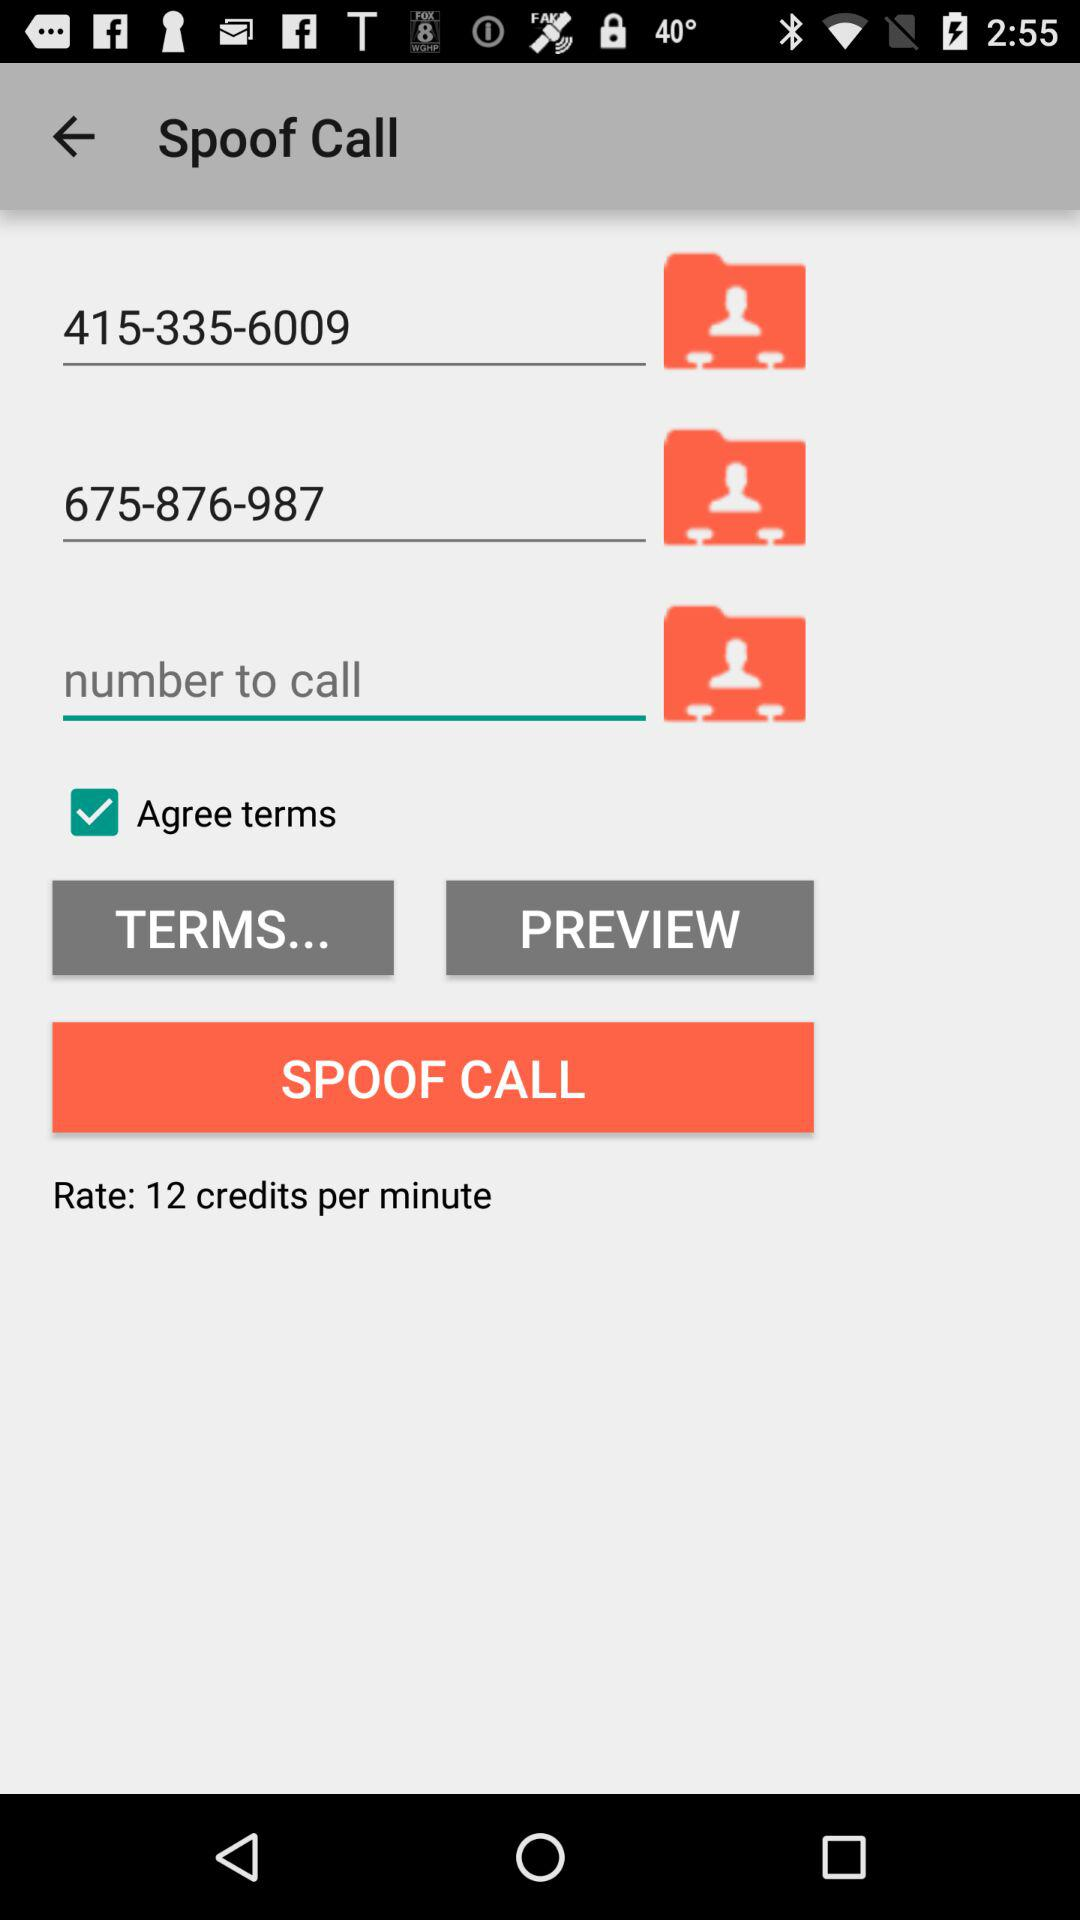What is the call rate? The call rate is 12 credits per minute. 